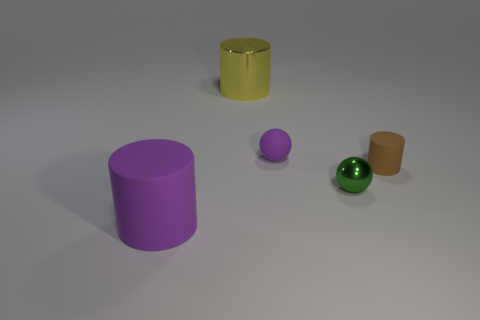There is a brown object that is the same shape as the big purple rubber object; what material is it?
Provide a short and direct response. Rubber. Are there any matte things of the same color as the matte ball?
Keep it short and to the point. Yes. Does the purple cylinder have the same material as the green thing?
Ensure brevity in your answer.  No. There is another object that is the same color as the large matte thing; what is its size?
Give a very brief answer. Small. There is a brown cylinder that is made of the same material as the purple cylinder; what size is it?
Give a very brief answer. Small. There is a purple rubber object that is right of the purple object in front of the small green shiny thing; what is its shape?
Your response must be concise. Sphere. What number of blue things are either tiny shiny things or big cylinders?
Make the answer very short. 0. There is a big thing that is behind the big thing that is in front of the yellow metallic object; is there a matte object right of it?
Your answer should be very brief. Yes. What shape is the big object that is the same color as the tiny rubber sphere?
Give a very brief answer. Cylinder. How many tiny things are either green cubes or balls?
Your answer should be compact. 2. 